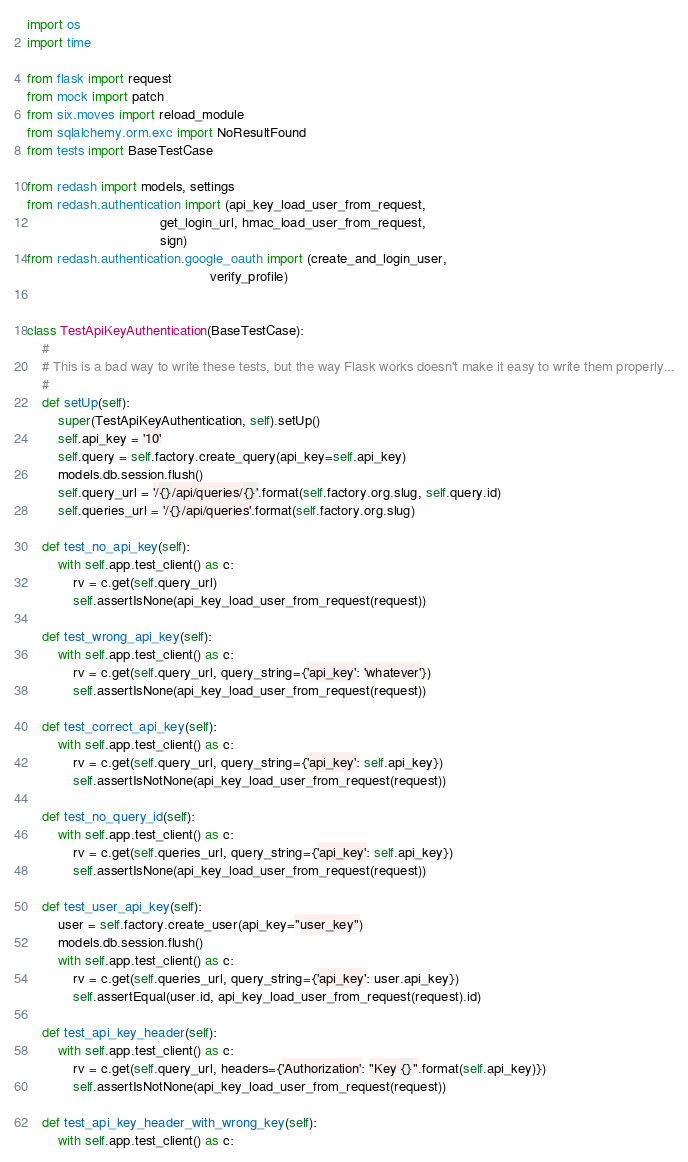Convert code to text. <code><loc_0><loc_0><loc_500><loc_500><_Python_>import os
import time

from flask import request
from mock import patch
from six.moves import reload_module
from sqlalchemy.orm.exc import NoResultFound
from tests import BaseTestCase

from redash import models, settings
from redash.authentication import (api_key_load_user_from_request,
                                   get_login_url, hmac_load_user_from_request,
                                   sign)
from redash.authentication.google_oauth import (create_and_login_user,
                                                verify_profile)


class TestApiKeyAuthentication(BaseTestCase):
    #
    # This is a bad way to write these tests, but the way Flask works doesn't make it easy to write them properly...
    #
    def setUp(self):
        super(TestApiKeyAuthentication, self).setUp()
        self.api_key = '10'
        self.query = self.factory.create_query(api_key=self.api_key)
        models.db.session.flush()
        self.query_url = '/{}/api/queries/{}'.format(self.factory.org.slug, self.query.id)
        self.queries_url = '/{}/api/queries'.format(self.factory.org.slug)

    def test_no_api_key(self):
        with self.app.test_client() as c:
            rv = c.get(self.query_url)
            self.assertIsNone(api_key_load_user_from_request(request))

    def test_wrong_api_key(self):
        with self.app.test_client() as c:
            rv = c.get(self.query_url, query_string={'api_key': 'whatever'})
            self.assertIsNone(api_key_load_user_from_request(request))

    def test_correct_api_key(self):
        with self.app.test_client() as c:
            rv = c.get(self.query_url, query_string={'api_key': self.api_key})
            self.assertIsNotNone(api_key_load_user_from_request(request))

    def test_no_query_id(self):
        with self.app.test_client() as c:
            rv = c.get(self.queries_url, query_string={'api_key': self.api_key})
            self.assertIsNone(api_key_load_user_from_request(request))

    def test_user_api_key(self):
        user = self.factory.create_user(api_key="user_key")
        models.db.session.flush()
        with self.app.test_client() as c:
            rv = c.get(self.queries_url, query_string={'api_key': user.api_key})
            self.assertEqual(user.id, api_key_load_user_from_request(request).id)

    def test_api_key_header(self):
        with self.app.test_client() as c:
            rv = c.get(self.query_url, headers={'Authorization': "Key {}".format(self.api_key)})
            self.assertIsNotNone(api_key_load_user_from_request(request))

    def test_api_key_header_with_wrong_key(self):
        with self.app.test_client() as c:</code> 